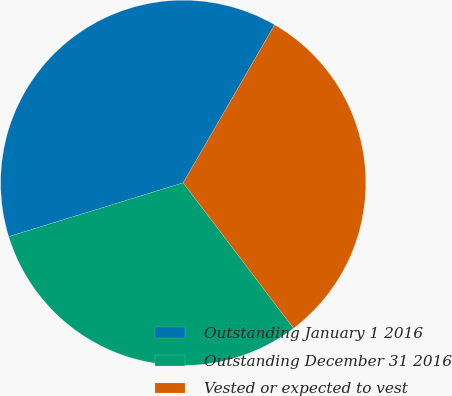Convert chart. <chart><loc_0><loc_0><loc_500><loc_500><pie_chart><fcel>Outstanding January 1 2016<fcel>Outstanding December 31 2016<fcel>Vested or expected to vest<nl><fcel>38.11%<fcel>30.57%<fcel>31.32%<nl></chart> 